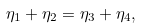Convert formula to latex. <formula><loc_0><loc_0><loc_500><loc_500>\eta _ { 1 } + \eta _ { 2 } = \eta _ { 3 } + \eta _ { 4 } ,</formula> 